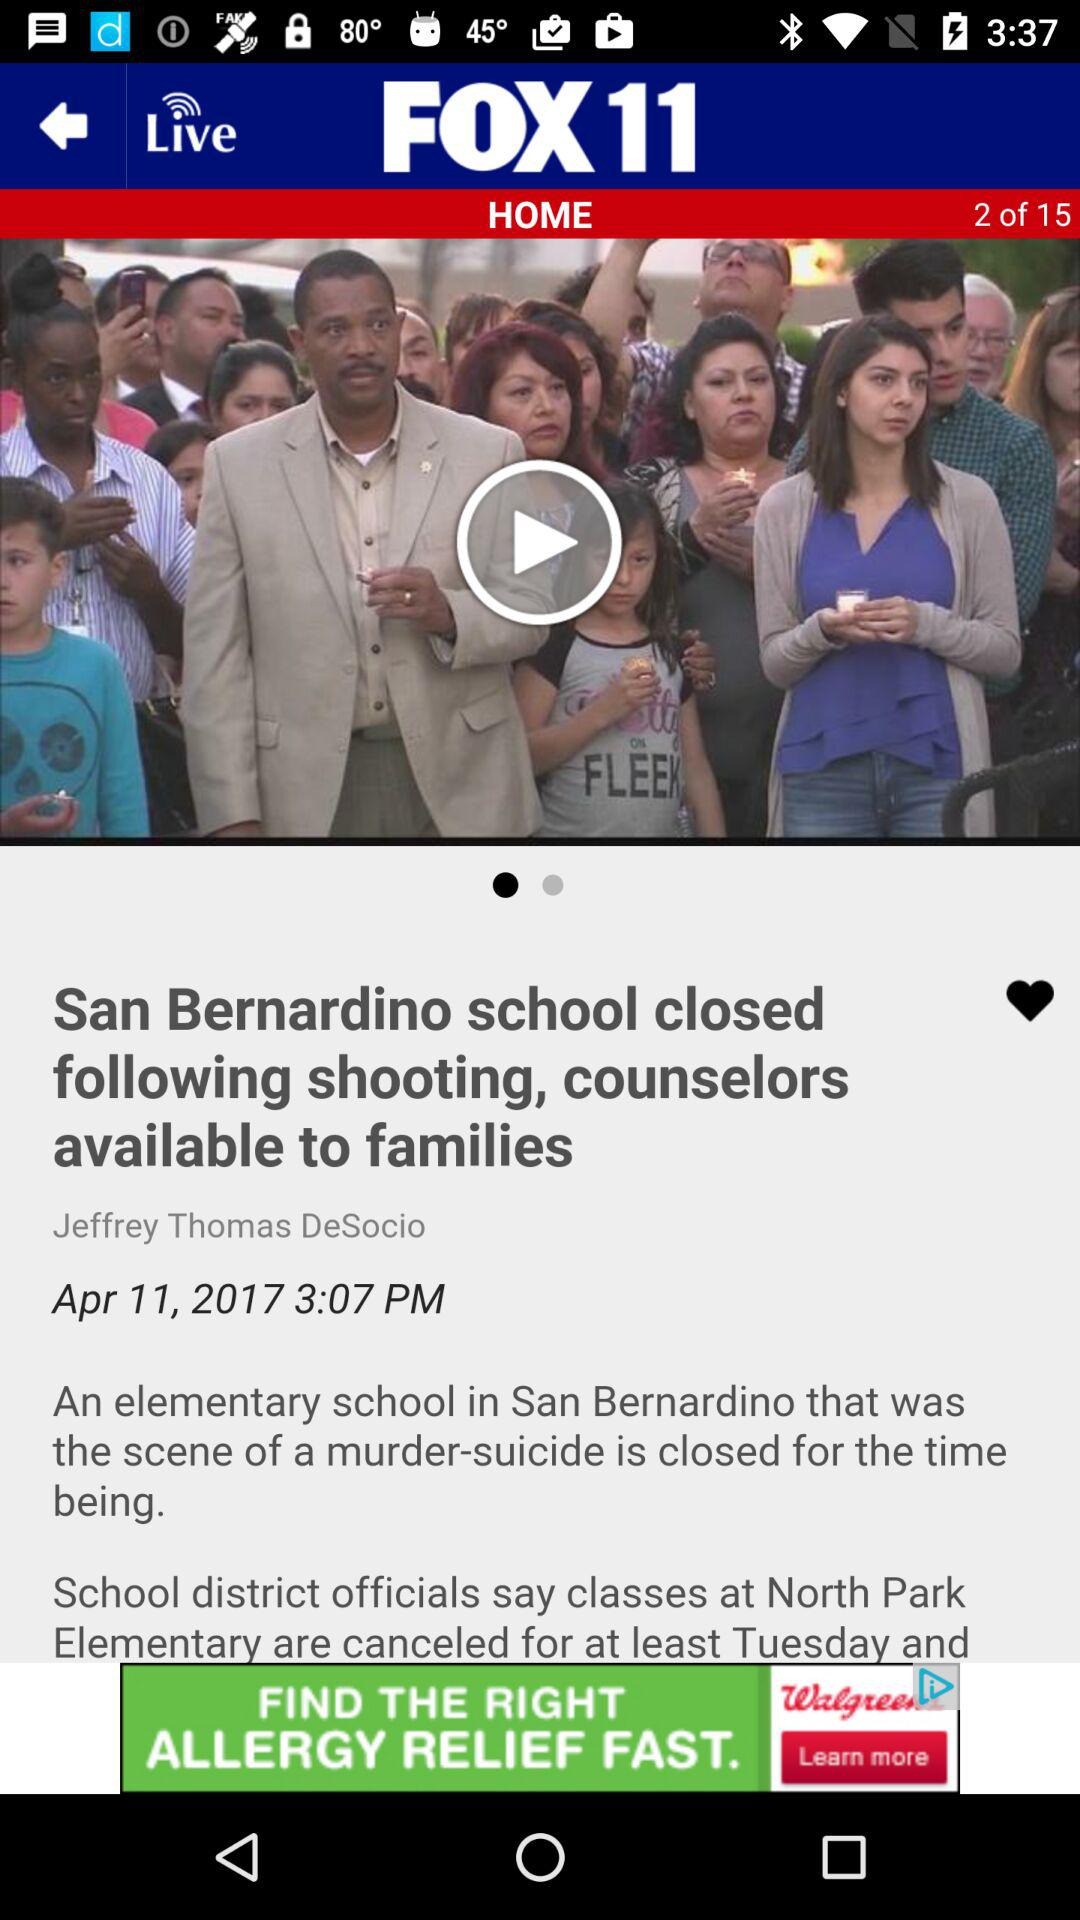How many reviews does this news article have?
When the provided information is insufficient, respond with <no answer>. <no answer> 